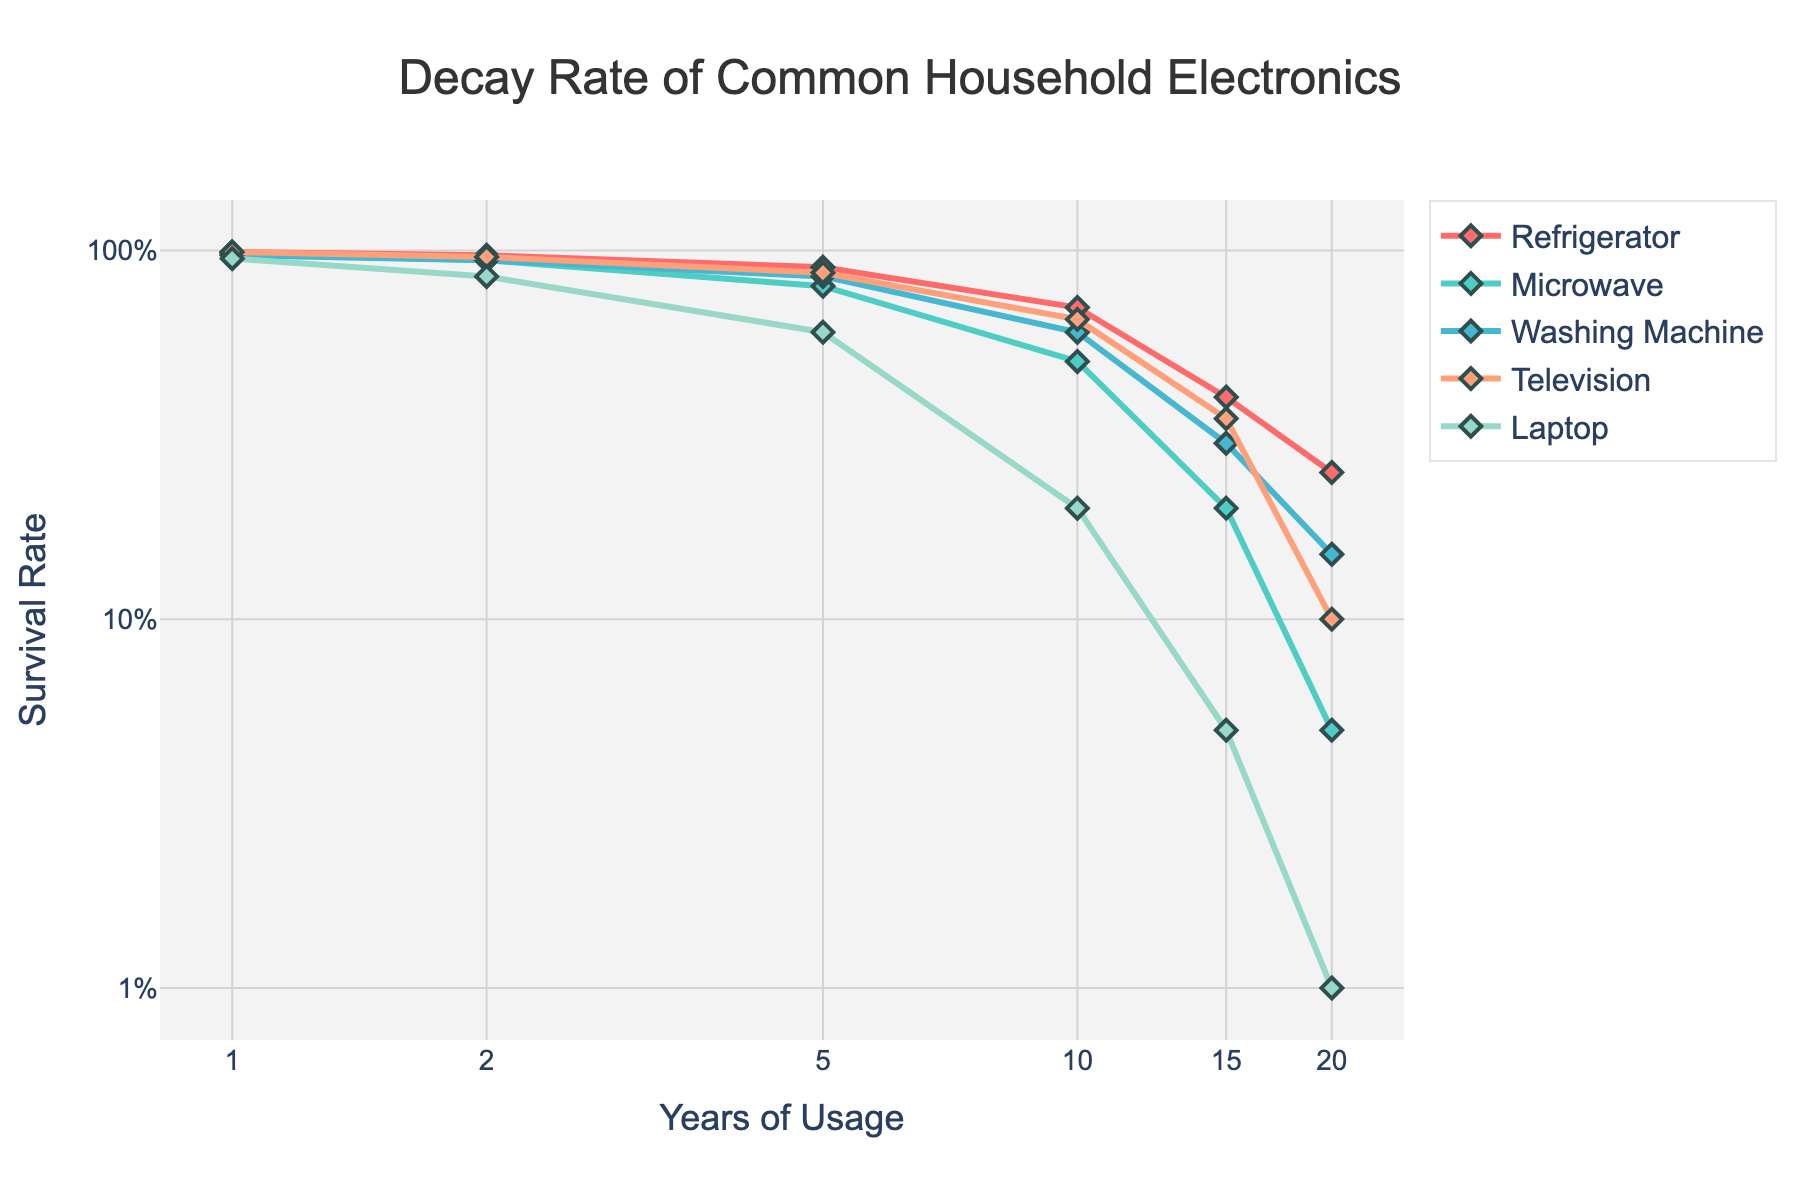Which appliance has the highest initial survival rate? To determine the highest initial survival rate, look at the survival rates at 1 year for all displayed appliances. The appliances and their survival rates at year 1 are: Refrigerator (0.99), Microwave (0.98), Washing Machine (0.97), Television (0.99), Laptop (0.95). The highest initial survival rate of 0.99 is shared between Refrigerator and Television.
Answer: Refrigerator, Television What is the survival rate of Washing Machine after 10 years? To find the survival rate of the Washing Machine after 10 years, locate the Washing Machine line on the graph and look for the value corresponding to 10 years on the x-axis. The survival rate at 10 years is indicated as 0.60.
Answer: 0.60 How does the survival rate of Microwave change from year 5 to year 10? To find the change in Microwave survival rate from year 5 to year 10, identify the survival rates at these two points: 0.80 at year 5 and 0.50 at year 10. The change is calculated as 0.50 - 0.80 = -0.30.
Answer: decreases by 0.30 Which appliance has the steepest decline in survival rate over 20 years? To determine the steepest decline, identify which appliance has the greatest drop from year 1 to year 20. The survival rates at these points are: Refrigerator (0.99 to 0.25), Microwave (0.98 to 0.05), Washing Machine (0.97 to 0.15), Television (0.99 to 0.10), Laptop (0.95 to 0.01). The greatest decline occurs for Microwave (0.05 - 0.98 = -0.93).
Answer: Microwave What is the average survival rate of the Refrigerator after 5, 10, and 15 years? To find the average survival rate for the Refrigerator at 5, 10, and 15 years, sum the survival rates at those points and divide by the number of points: (0.90 + 0.70 + 0.40)/3 = 2.00/3 ≈ 0.67.
Answer: 0.67 Compare the survival rates of Television and Laptop at 10 years and state which is higher. To compare, locate the survival rates of both Television and Laptop at 10 years. Television has a survival rate of 0.65, and Laptop has a survival rate of 0.20. Television’s survival rate is higher.
Answer: Television Which appliance has the least variation in its survival rate over time? To determine the least variation, observe the flatness of the plot lines and the closeness of the points throughout the 20 years. The flatter the line, the lesser the variation. By observing the lines' steepness, the Refrigerator, which goes from 0.99 to 0.25, shows a relatively moderate drop, indicating the least variation compared to others.
Answer: Refrigerator What are the survival rates of the Laptop at 1, 5, and 20 years, and how do they compare to each other? Identify the Laptop's survival rates at 1 year (0.95), 5 years (0.60), and 20 years (0.01). Comparing these, the survival rate shows a noticeable decrease over time, from 0.95 to 0.60, and a dramatic drop to 0.01 by the 20th year.
Answer: 0.95, 0.60, 0.01 